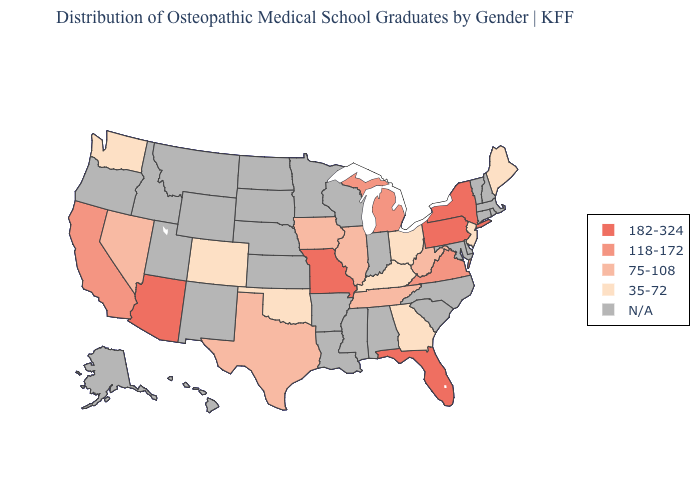What is the lowest value in the USA?
Be succinct. 35-72. Among the states that border New York , which have the lowest value?
Keep it brief. New Jersey. Is the legend a continuous bar?
Write a very short answer. No. Among the states that border Georgia , does Florida have the lowest value?
Short answer required. No. Name the states that have a value in the range 182-324?
Keep it brief. Arizona, Florida, Missouri, New York, Pennsylvania. What is the lowest value in the USA?
Answer briefly. 35-72. Name the states that have a value in the range 182-324?
Quick response, please. Arizona, Florida, Missouri, New York, Pennsylvania. What is the highest value in the USA?
Short answer required. 182-324. What is the value of South Carolina?
Keep it brief. N/A. Is the legend a continuous bar?
Answer briefly. No. What is the value of Arizona?
Answer briefly. 182-324. What is the value of Tennessee?
Keep it brief. 75-108. What is the lowest value in the West?
Quick response, please. 35-72. Which states hav the highest value in the MidWest?
Quick response, please. Missouri. What is the highest value in states that border Mississippi?
Be succinct. 75-108. 